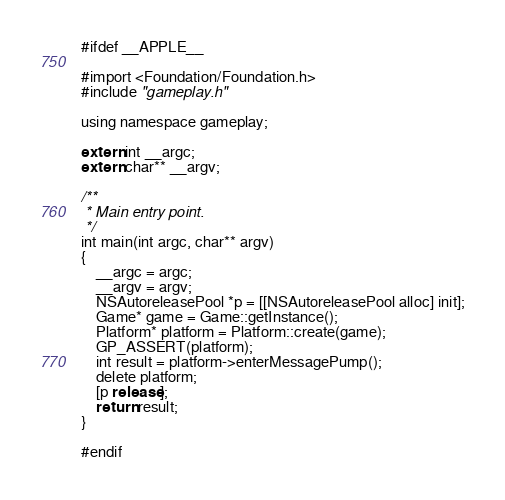Convert code to text. <code><loc_0><loc_0><loc_500><loc_500><_ObjectiveC_>#ifdef __APPLE__

#import <Foundation/Foundation.h>
#include "gameplay.h"

using namespace gameplay;

extern int __argc;
extern char** __argv;

/**
 * Main entry point.
 */
int main(int argc, char** argv)
{
    __argc = argc;
    __argv = argv;
    NSAutoreleasePool *p = [[NSAutoreleasePool alloc] init];
    Game* game = Game::getInstance();
    Platform* platform = Platform::create(game);
    GP_ASSERT(platform);
    int result = platform->enterMessagePump();
    delete platform;
    [p release];
    return result;
}

#endif</code> 